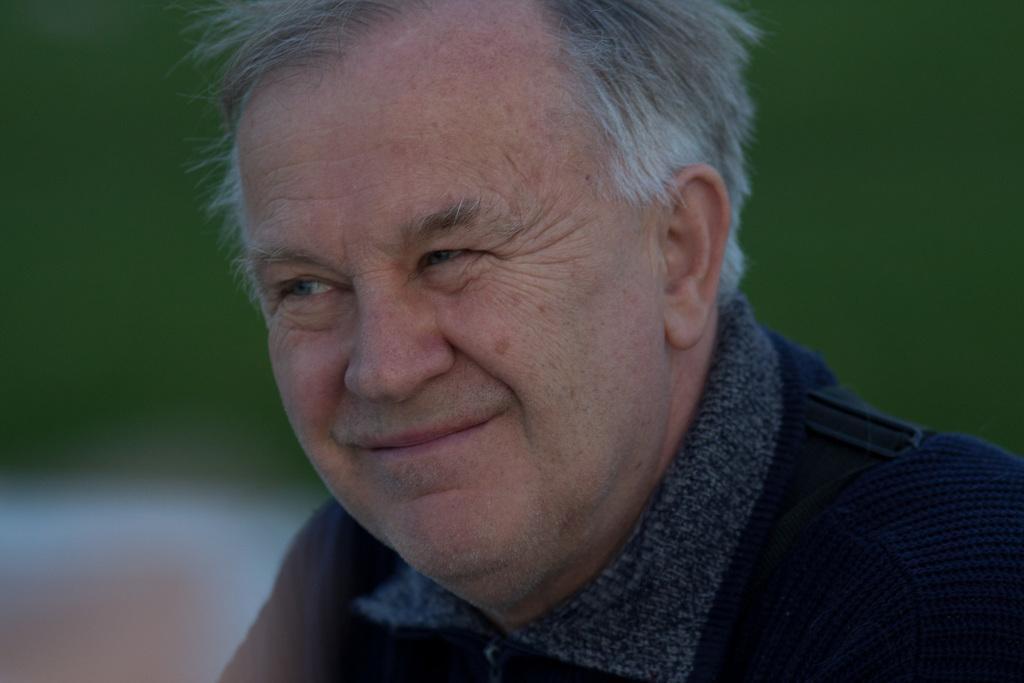Can you describe this image briefly? Here in this picture we can see an old man present over there and we can see he is smiling. 